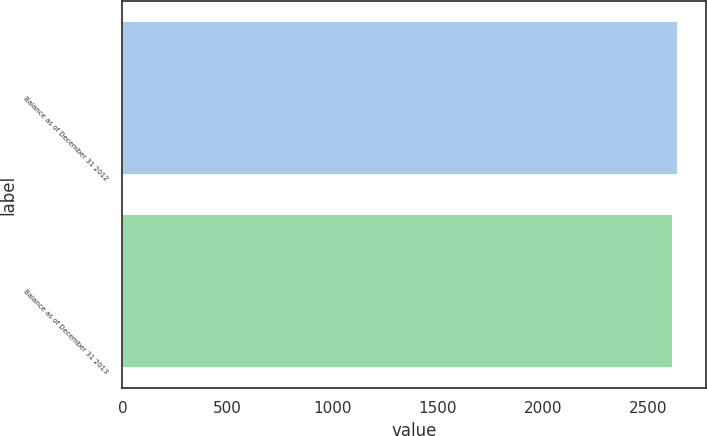Convert chart. <chart><loc_0><loc_0><loc_500><loc_500><bar_chart><fcel>Balance as of December 31 2012<fcel>Balance as of December 31 2013<nl><fcel>2644<fcel>2618<nl></chart> 